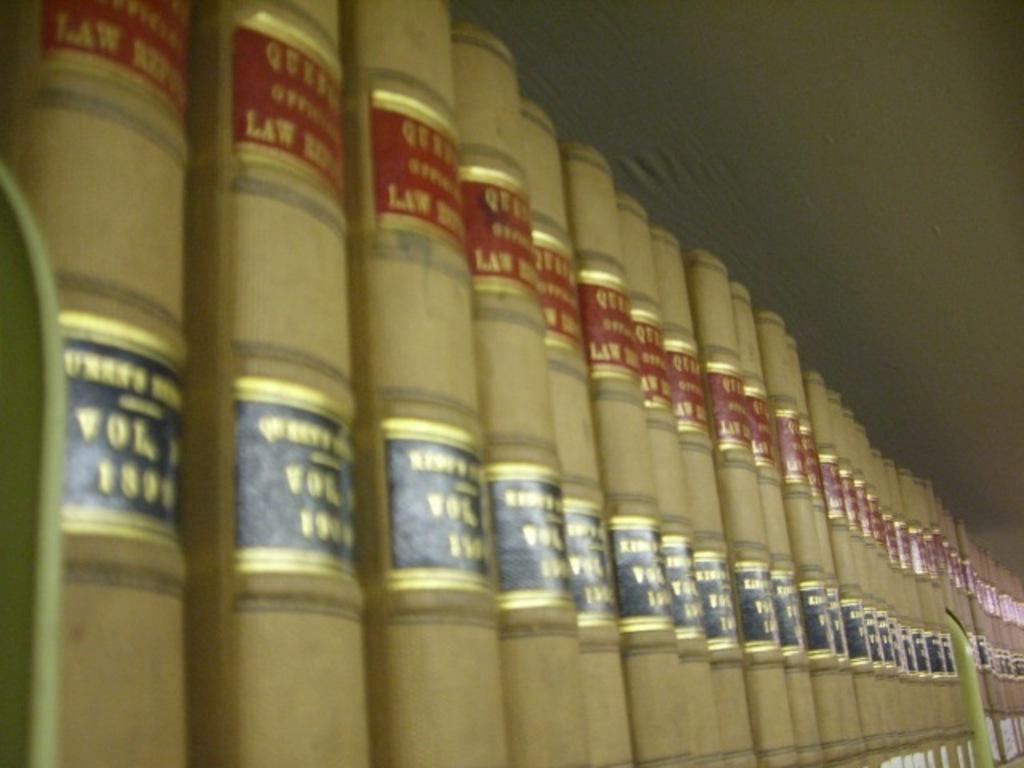Is there multiple volumes of these books?
Your response must be concise. Yes. 